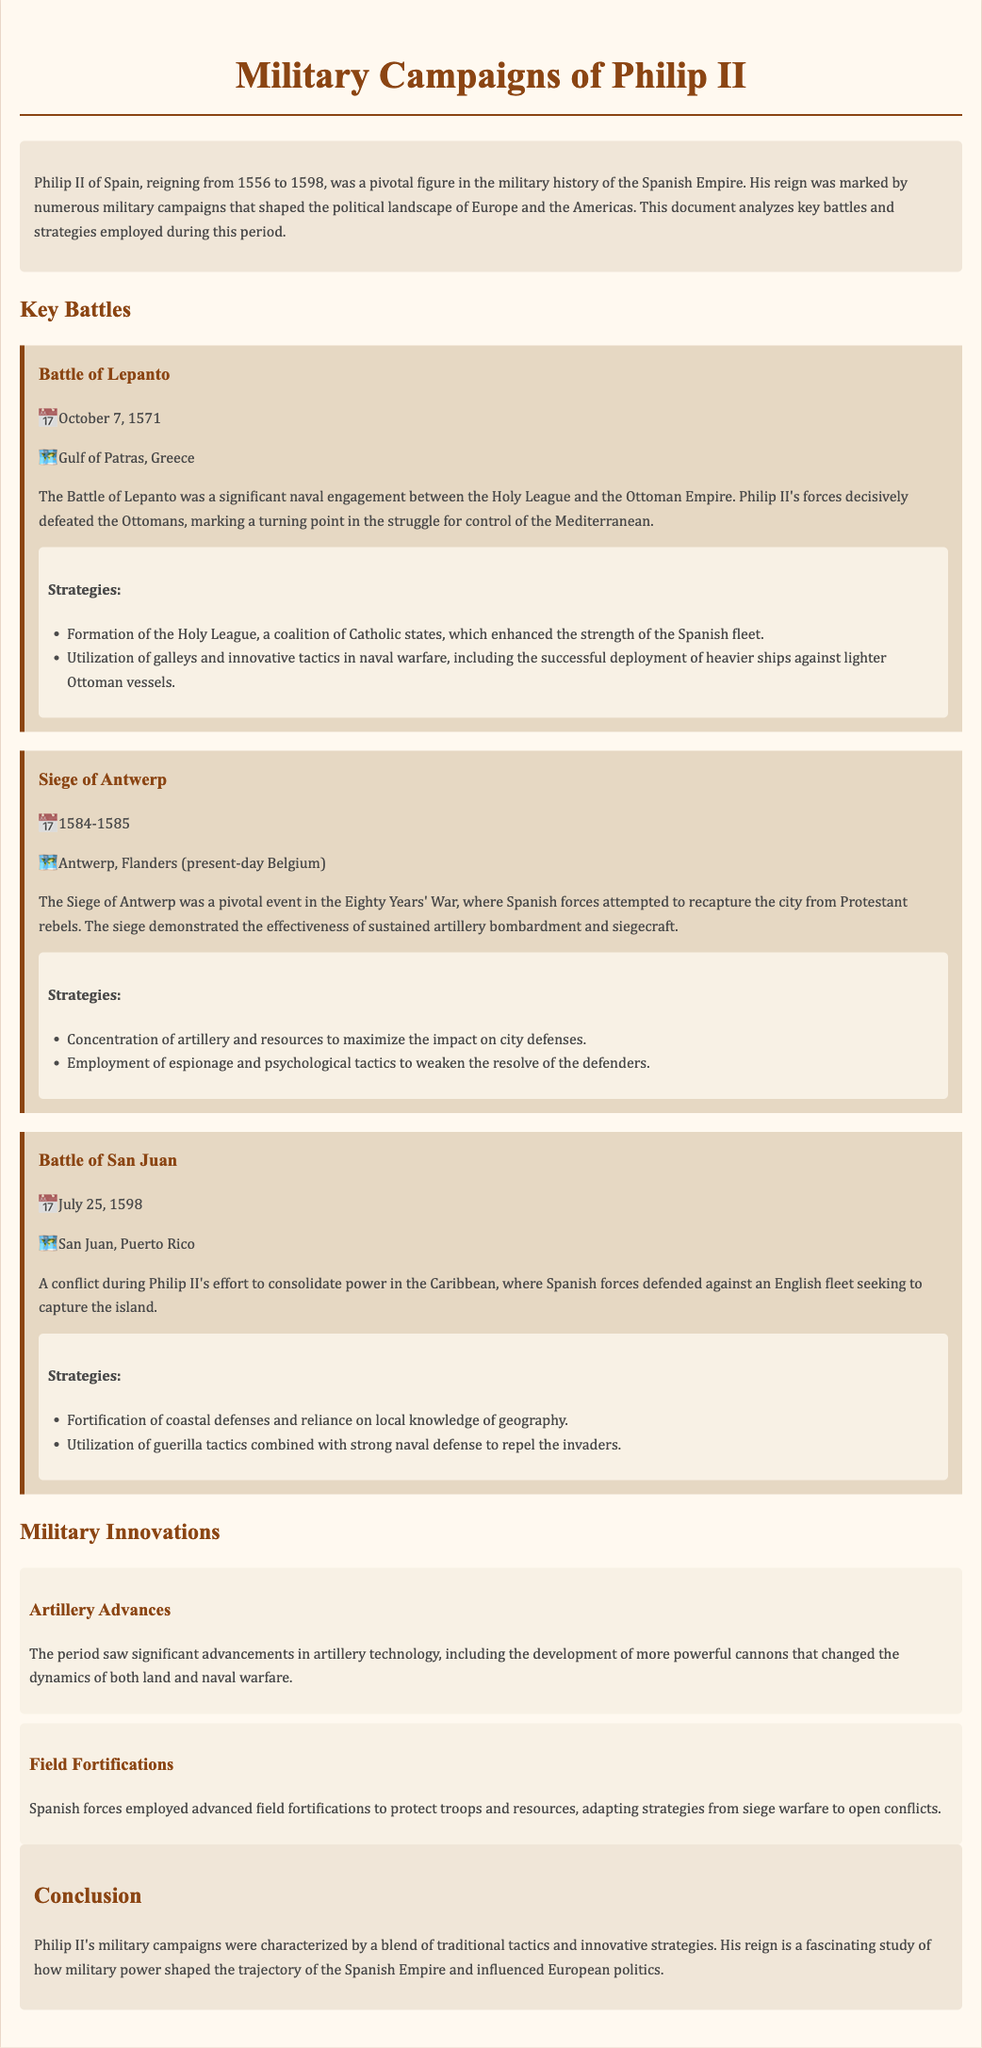What date did the Battle of Lepanto occur? The document states that the Battle of Lepanto took place on October 7, 1571.
Answer: October 7, 1571 Where was the Siege of Antwerp located? The Siege of Antwerp was located in Antwerp, Flanders (present-day Belgium).
Answer: Antwerp, Flanders What was one of the strategies used in the Battle of Lepanto? The document lists the formation of the Holy League as a strategy used during the Battle of Lepanto.
Answer: Formation of the Holy League Which battle occurred on July 25, 1598? The document mentions that the Battle of San Juan occurred on this date.
Answer: Battle of San Juan What significant military innovation is noted in the document? The document highlights advances in artillery technology as a significant military innovation during Philip II's reign.
Answer: Artillery Advances Which two tactics were used in the Siege of Antwerp? The document describes the concentration of artillery and the use of espionage as two tactics used in the Siege of Antwerp.
Answer: Concentration of artillery and espionage What important event did Philip II's reign coincide with? The document states that Philip II's military campaigns happened during the Eighty Years' War.
Answer: Eighty Years' War What geographical advantage was utilized in the Battle of San Juan? The document mentions relying on local knowledge of geography as a geographical advantage in the Battle of San Juan.
Answer: Local knowledge of geography What is the main focus of the document? The document primarily focuses on analyzing key battles and strategies employed during Philip II's reign.
Answer: Key battles and strategies 